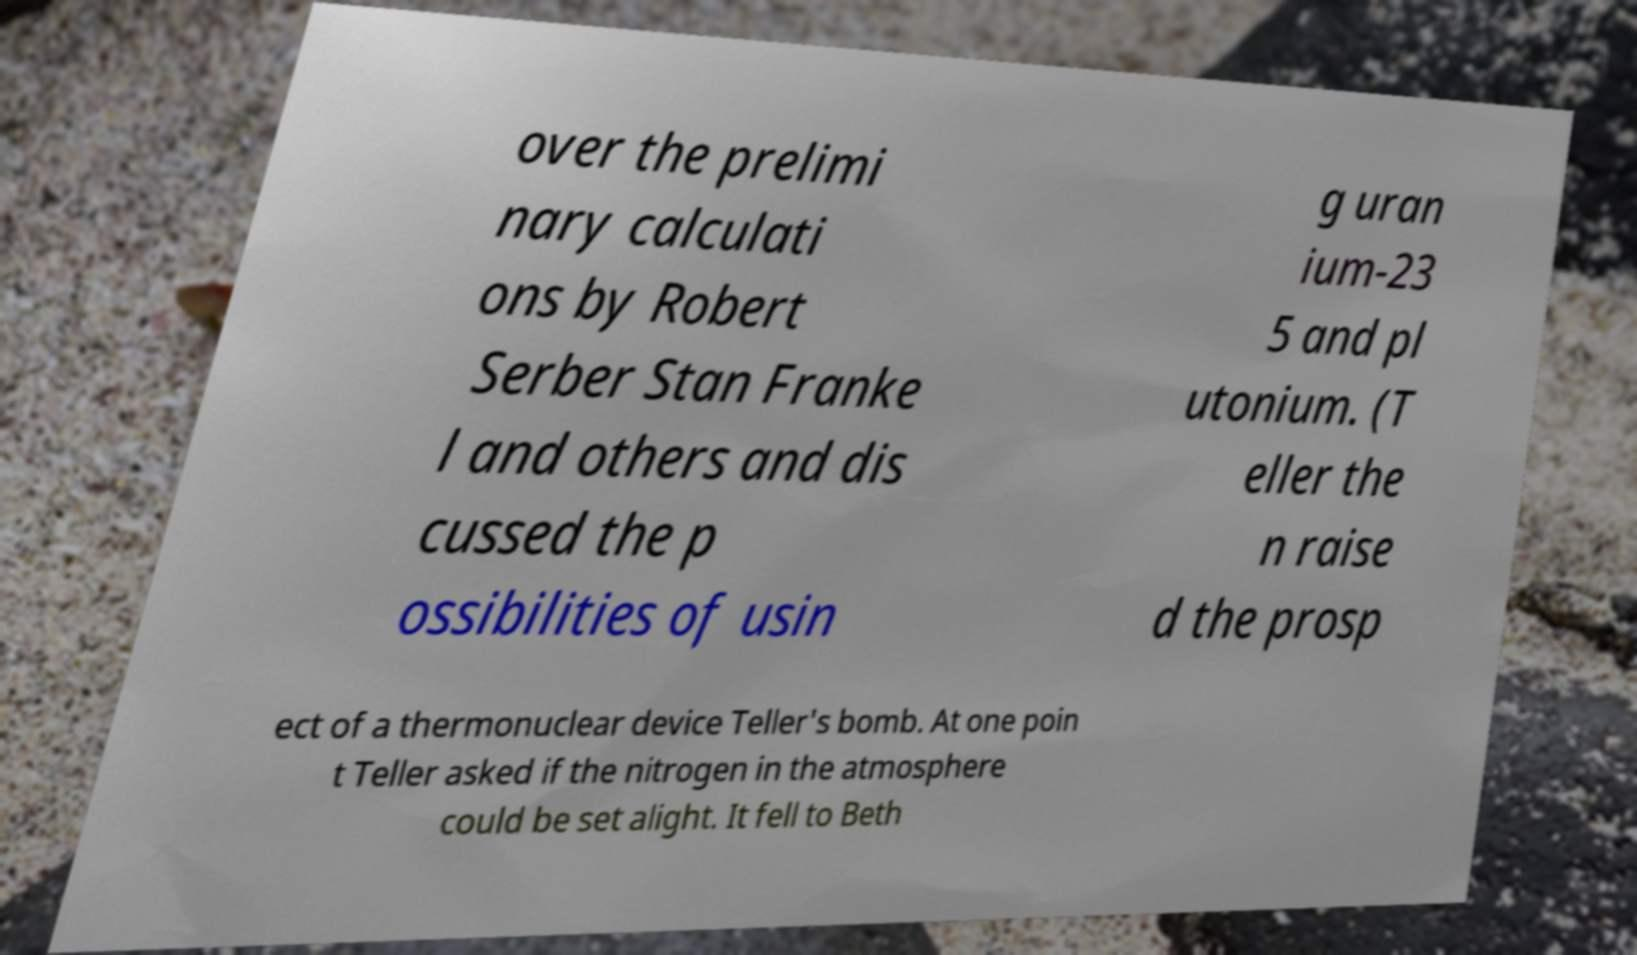Can you read and provide the text displayed in the image?This photo seems to have some interesting text. Can you extract and type it out for me? over the prelimi nary calculati ons by Robert Serber Stan Franke l and others and dis cussed the p ossibilities of usin g uran ium-23 5 and pl utonium. (T eller the n raise d the prosp ect of a thermonuclear device Teller's bomb. At one poin t Teller asked if the nitrogen in the atmosphere could be set alight. It fell to Beth 